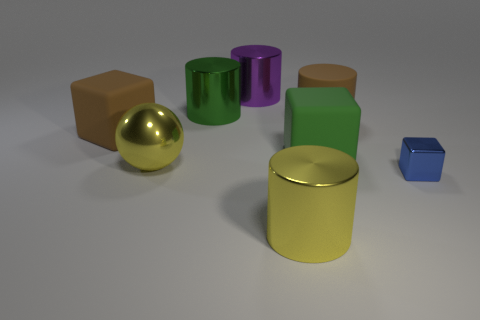Add 1 big green rubber cubes. How many objects exist? 9 Subtract all balls. How many objects are left? 7 Add 7 matte cylinders. How many matte cylinders are left? 8 Add 3 green matte blocks. How many green matte blocks exist? 4 Subtract 0 green spheres. How many objects are left? 8 Subtract all purple metallic cylinders. Subtract all large yellow shiny balls. How many objects are left? 6 